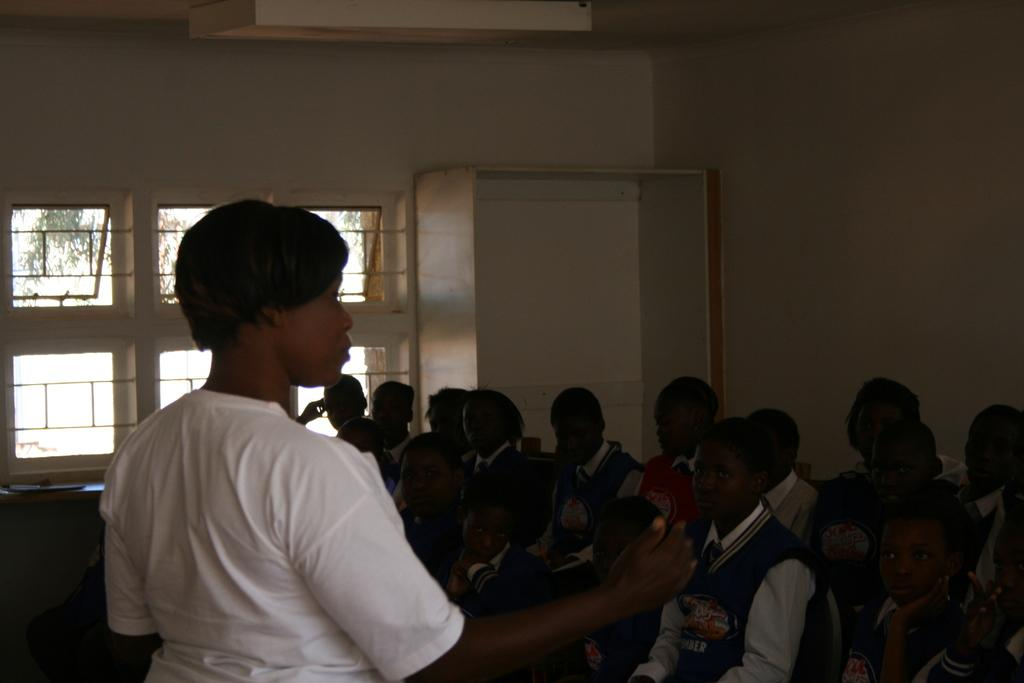Who are the people in the image? There are children and a woman in the image. What can be seen in the background of the image? There is a wall, a window, and a rack in the background of the image. What language is the woman speaking in the image? There is no indication of the language being spoken in the image. Who is the owner of the rack in the background? There is no information about the ownership of the rack in the image. 